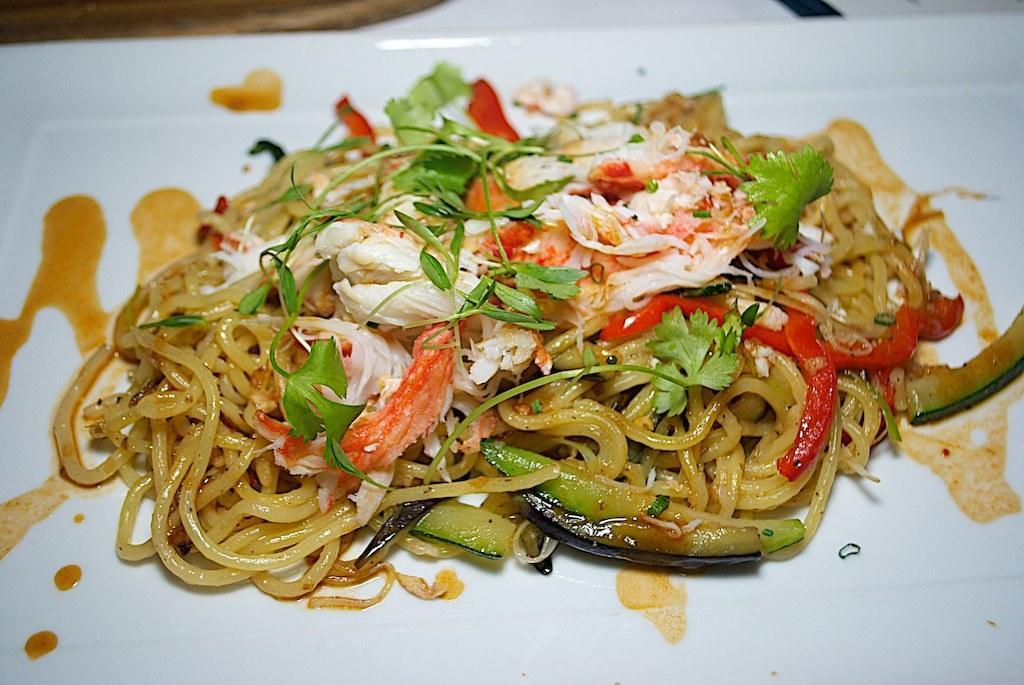Can you describe this image briefly? In this image there is a food item on the plate. 